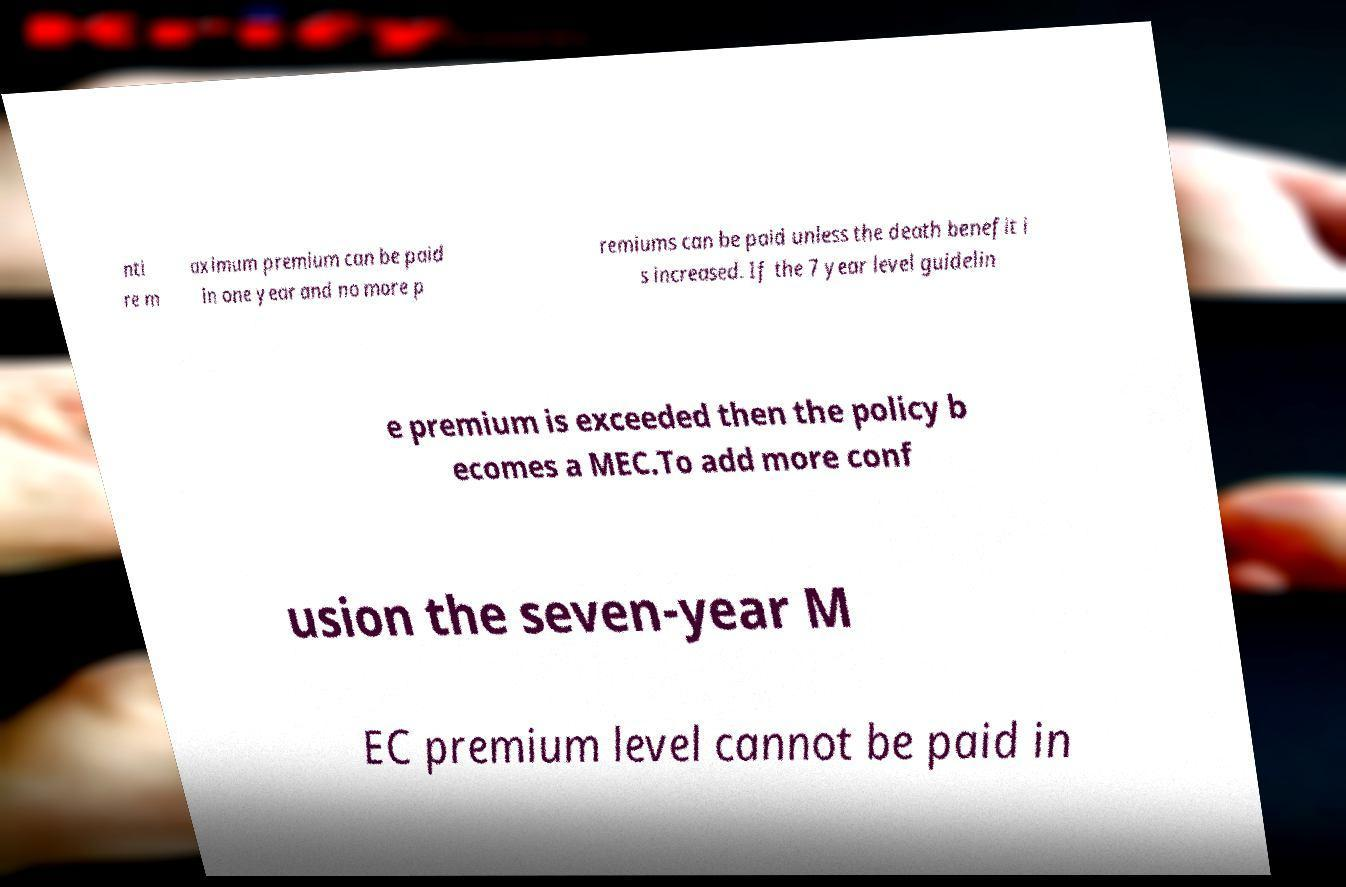For documentation purposes, I need the text within this image transcribed. Could you provide that? nti re m aximum premium can be paid in one year and no more p remiums can be paid unless the death benefit i s increased. If the 7 year level guidelin e premium is exceeded then the policy b ecomes a MEC.To add more conf usion the seven-year M EC premium level cannot be paid in 